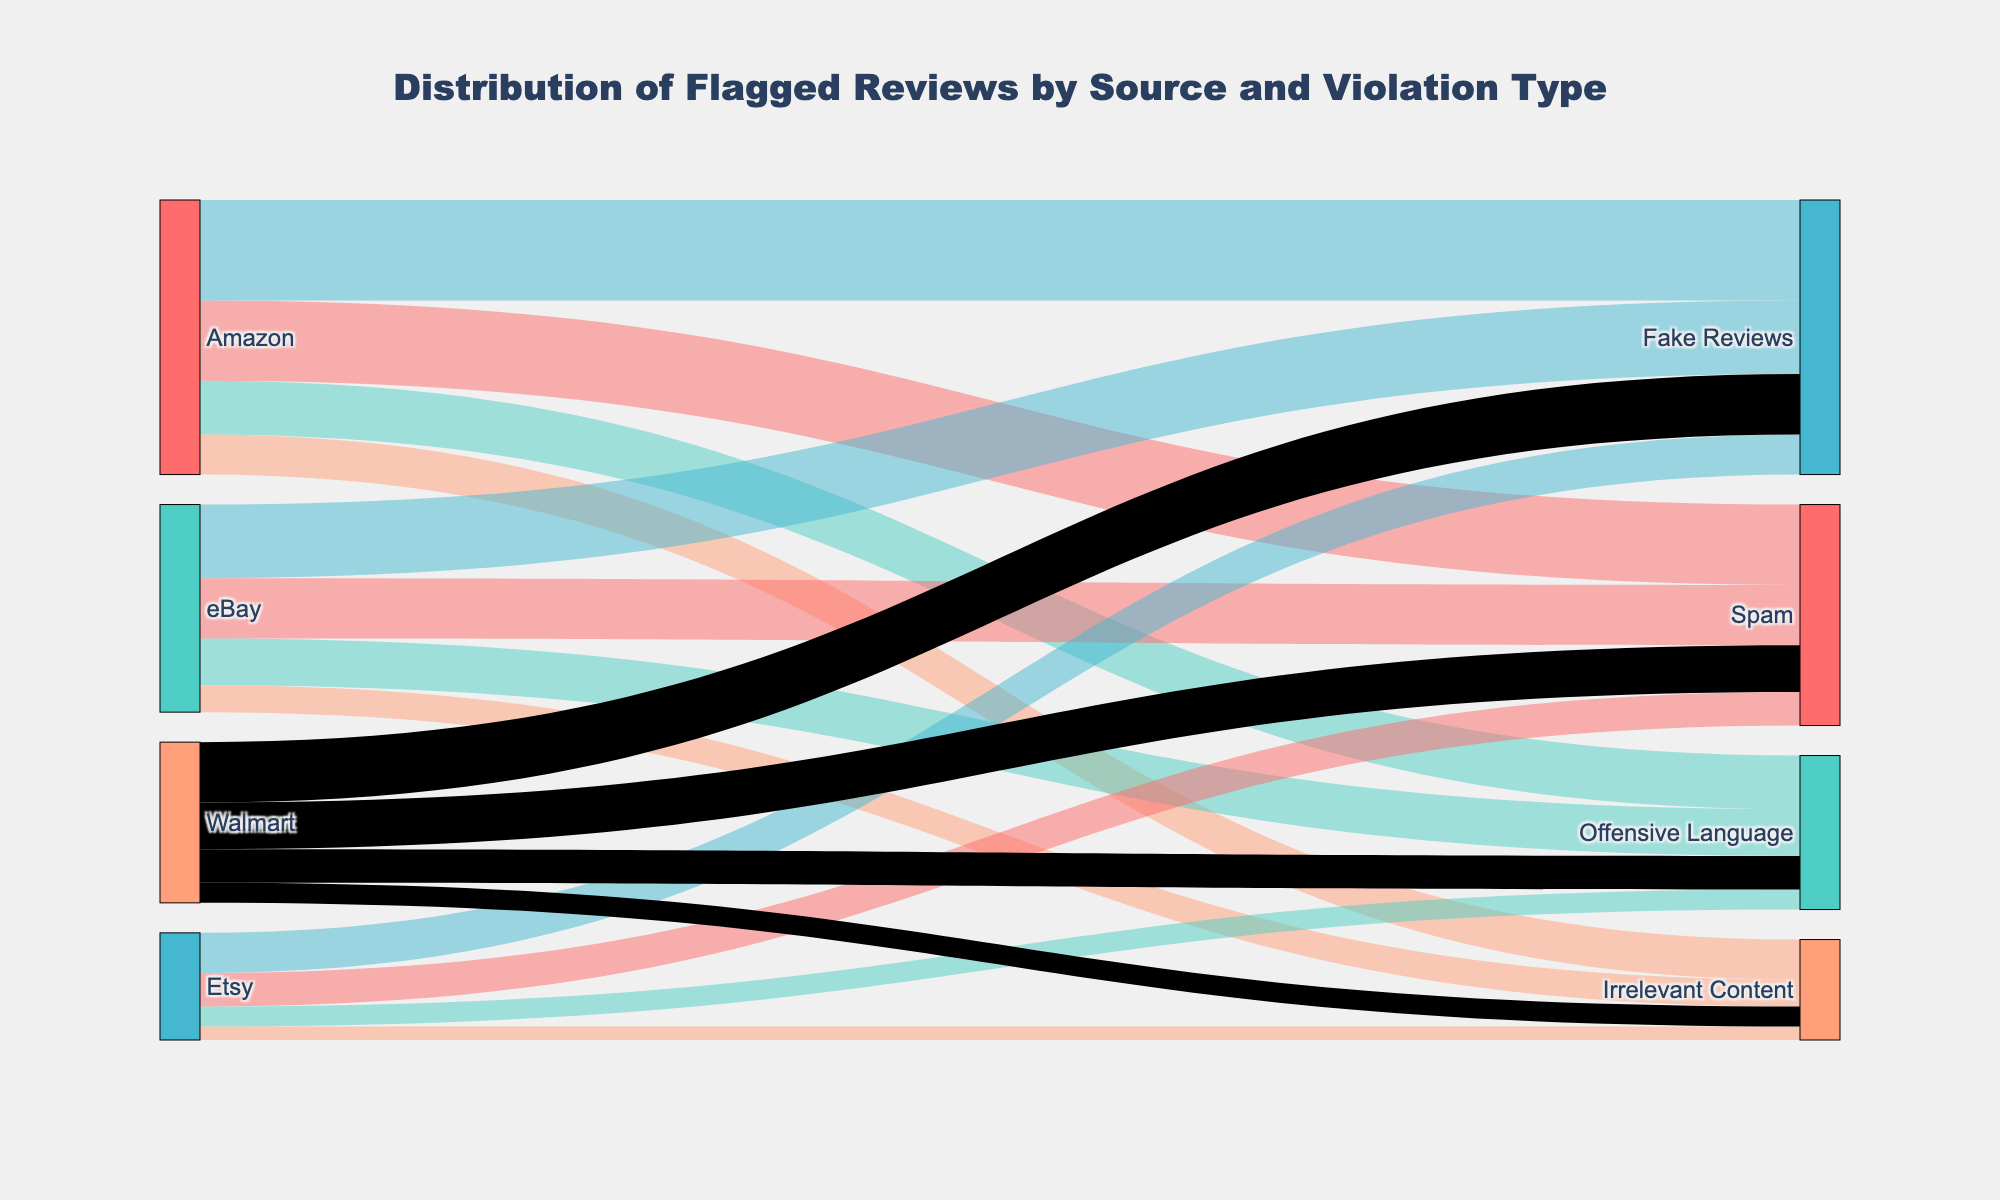What is the source with the highest number of flagged reviews? To find this, sum the counts for each source: Amazon (1200 + 800 + 1500 + 600 = 4100), eBay (900 + 700 + 1100 + 400 = 3100), Etsy (500 + 300 + 600 + 200 = 1600), Walmart (700 + 500 + 900 + 300 = 2400). Amazon has the highest total.
Answer: Amazon How many flagged reviews were identified for Fake Reviews across all sources? Add the counts for Fake Reviews by each source: Amazon (1500), eBay (1100), Etsy (600), Walmart (900). Total is (1500 + 1100 + 600 + 900 = 4100).
Answer: 4100 Which source has more flagged reviews for Spam, Amazon or eBay? Compare the counts for Spam: Amazon (1200), eBay (900). Amazon has more flagged reviews for Spam.
Answer: Amazon What is the total number of flagged reviews for Offensive Language across all sources? Add the counts for Offensive Language by each source: Amazon (800), eBay (700), Etsy (300), Walmart (500). Total is (800 + 700 + 300 + 500 = 2300).
Answer: 2300 How does the number of flagged reviews for Irrelevant Content from Walmart compare to Etsy? Compare the counts for Irrelevant Content: Walmart (300), Etsy (200). Walmart has more flagged reviews for Irrelevant Content.
Answer: Walmart Which violation type has the lowest count on Etsy? Review the counts for each violation type on Etsy: Spam (500), Offensive Language (300), Fake Reviews (600), Irrelevant Content (200). Irrelevant Content has the lowest count.
Answer: Irrelevant Content What is the sum of flagged reviews for all violation types on eBay? Add the counts for all violation types on eBay: Spam (900), Offensive Language (700), Fake Reviews (1100), Irrelevant Content (400). Total is (900 + 700 + 1100 + 400 = 3100).
Answer: 3100 Which violation type has the highest count overall? Sum the counts for each violation type across all sources: Spam (1200 + 900 + 500 + 700 = 3300), Offensive Language (800 + 700 + 300 + 500 = 2300), Fake Reviews (1500 + 1100 + 600 + 900 = 4100), Irrelevant Content (600 + 400 + 200 + 300 = 1500). Fake Reviews has the highest count overall.
Answer: Fake Reviews 